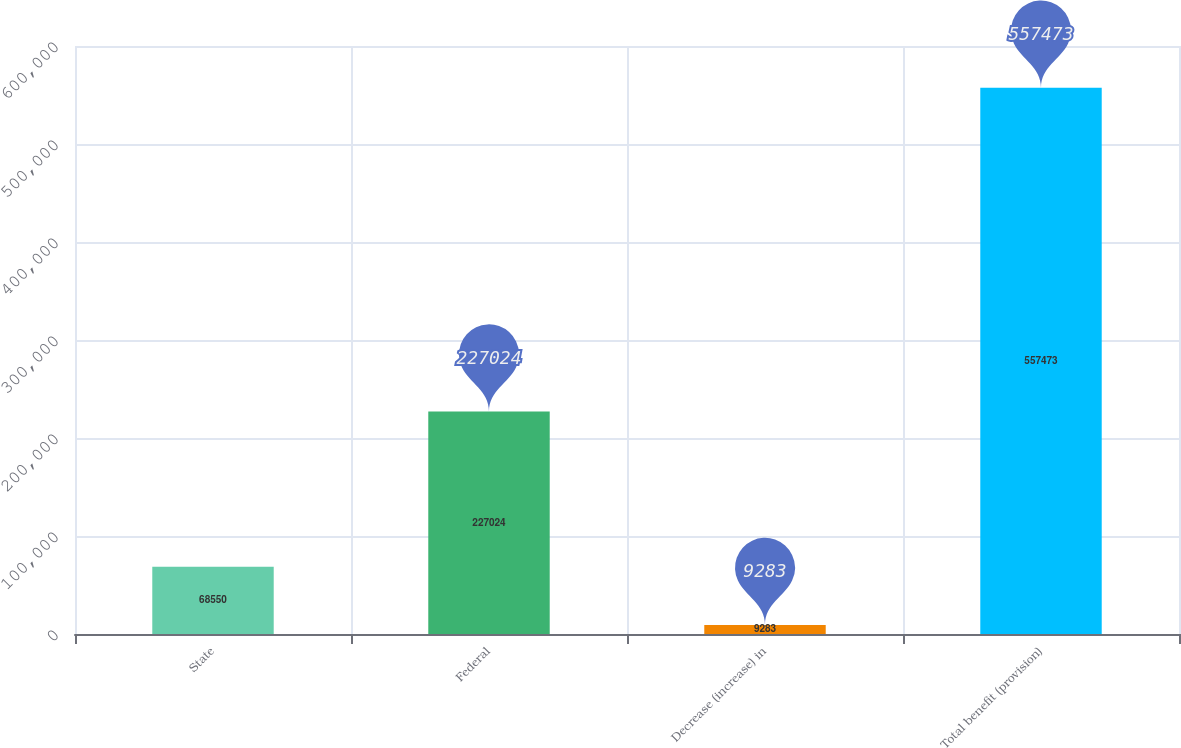<chart> <loc_0><loc_0><loc_500><loc_500><bar_chart><fcel>State<fcel>Federal<fcel>Decrease (increase) in<fcel>Total benefit (provision)<nl><fcel>68550<fcel>227024<fcel>9283<fcel>557473<nl></chart> 